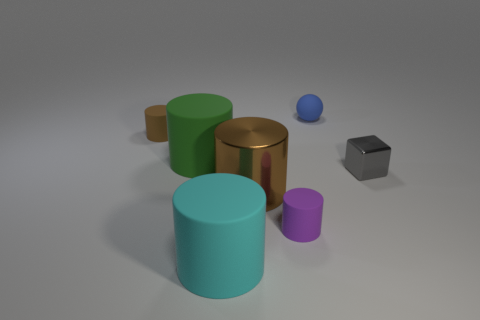Which object seems to be the tallest, and what color is it? The tallest object in the image is the green cylinder, which has a rich, emerald hue. Could you describe the texture of the objects that are the same color as the tallest one? The items sharing the same color as the tallest green cylinder, which includes another smaller cylinder, appear to have a matte finish with slight variations in shading, suggesting a non-reflective surface texture. 